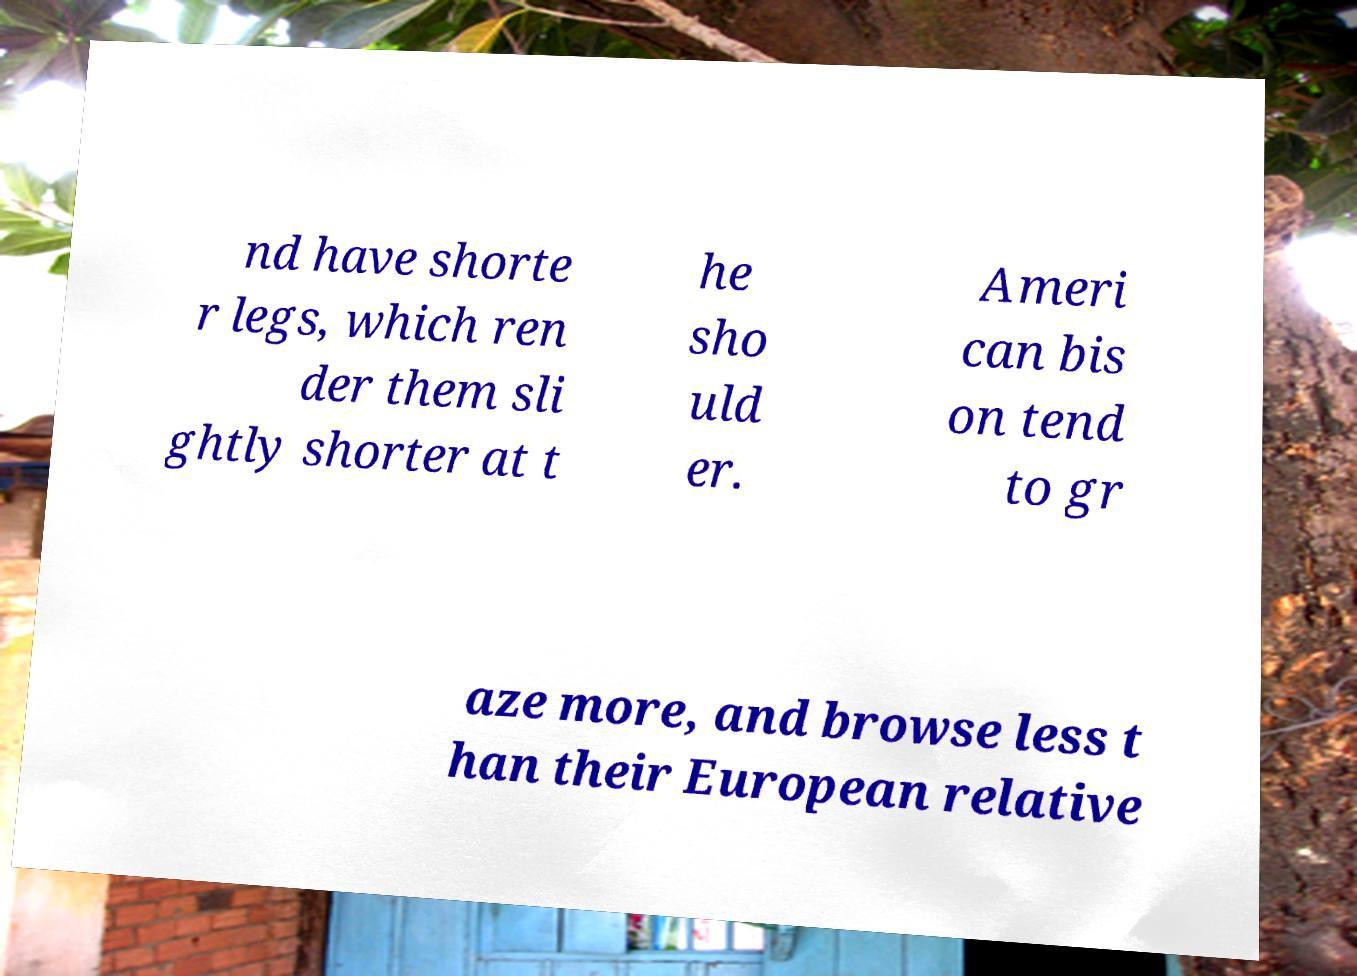What messages or text are displayed in this image? I need them in a readable, typed format. nd have shorte r legs, which ren der them sli ghtly shorter at t he sho uld er. Ameri can bis on tend to gr aze more, and browse less t han their European relative 